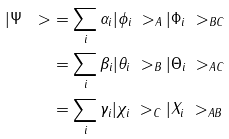Convert formula to latex. <formula><loc_0><loc_0><loc_500><loc_500>| \Psi \ > & = \sum _ { i } \alpha _ { i } | \phi _ { i } \ > _ { A } | \Phi _ { i } \ > _ { B C } \\ & = \sum _ { i } \beta _ { i } | \theta _ { i } \ > _ { B } | \Theta _ { i } \ > _ { A C } \\ & = \sum _ { i } \gamma _ { i } | \chi _ { i } \ > _ { C } | X _ { i } \ > _ { A B }</formula> 